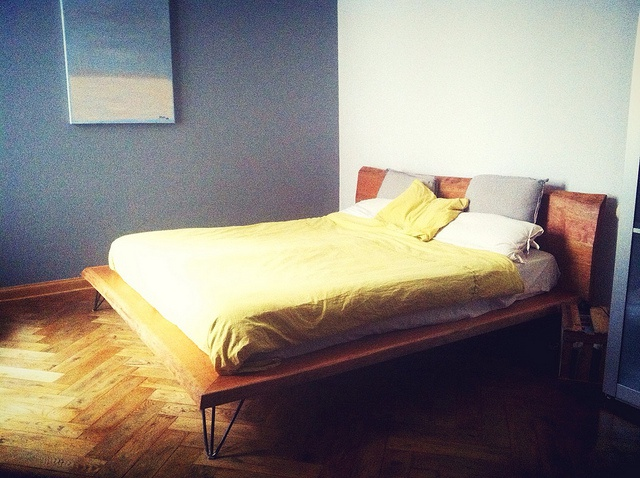Describe the objects in this image and their specific colors. I can see a bed in navy, beige, khaki, black, and maroon tones in this image. 